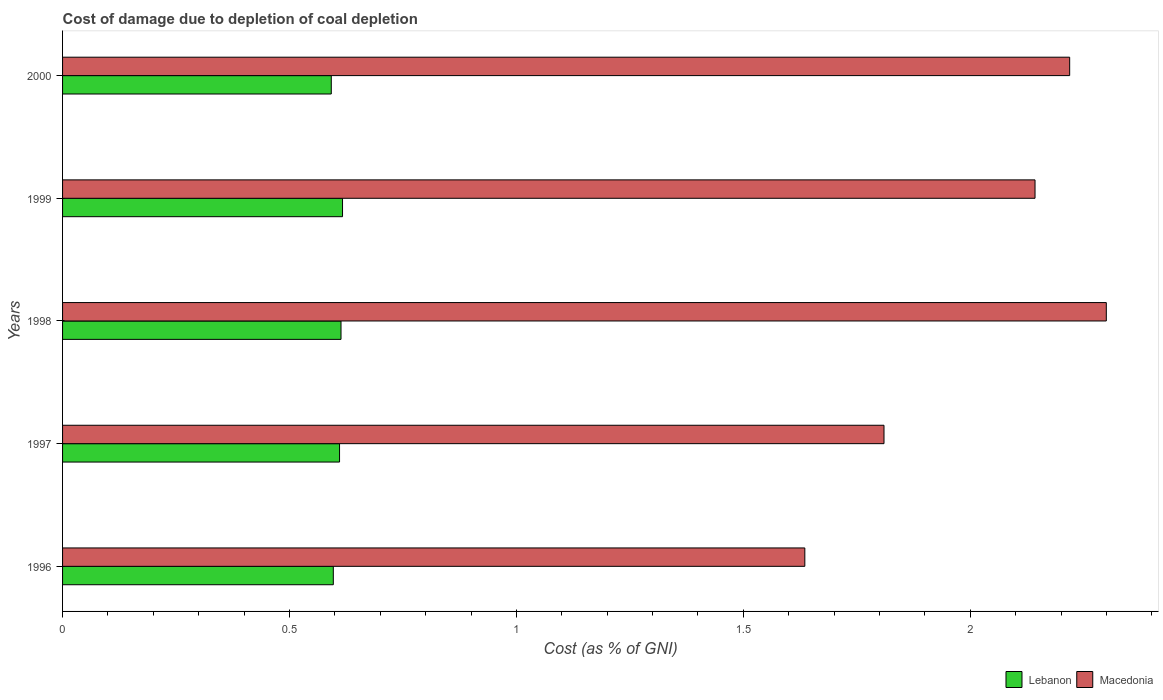How many different coloured bars are there?
Your answer should be compact. 2. How many groups of bars are there?
Provide a succinct answer. 5. Are the number of bars on each tick of the Y-axis equal?
Keep it short and to the point. Yes. How many bars are there on the 1st tick from the bottom?
Offer a terse response. 2. What is the label of the 2nd group of bars from the top?
Ensure brevity in your answer.  1999. In how many cases, is the number of bars for a given year not equal to the number of legend labels?
Provide a short and direct response. 0. What is the cost of damage caused due to coal depletion in Lebanon in 1998?
Make the answer very short. 0.61. Across all years, what is the maximum cost of damage caused due to coal depletion in Macedonia?
Ensure brevity in your answer.  2.3. Across all years, what is the minimum cost of damage caused due to coal depletion in Lebanon?
Your answer should be very brief. 0.59. In which year was the cost of damage caused due to coal depletion in Macedonia maximum?
Offer a terse response. 1998. What is the total cost of damage caused due to coal depletion in Lebanon in the graph?
Ensure brevity in your answer.  3.03. What is the difference between the cost of damage caused due to coal depletion in Lebanon in 1997 and that in 1999?
Keep it short and to the point. -0.01. What is the difference between the cost of damage caused due to coal depletion in Lebanon in 1998 and the cost of damage caused due to coal depletion in Macedonia in 1997?
Give a very brief answer. -1.2. What is the average cost of damage caused due to coal depletion in Macedonia per year?
Provide a succinct answer. 2.02. In the year 1997, what is the difference between the cost of damage caused due to coal depletion in Macedonia and cost of damage caused due to coal depletion in Lebanon?
Your answer should be compact. 1.2. What is the ratio of the cost of damage caused due to coal depletion in Lebanon in 1998 to that in 1999?
Provide a short and direct response. 0.99. What is the difference between the highest and the second highest cost of damage caused due to coal depletion in Macedonia?
Make the answer very short. 0.08. What is the difference between the highest and the lowest cost of damage caused due to coal depletion in Macedonia?
Provide a succinct answer. 0.66. What does the 2nd bar from the top in 2000 represents?
Your answer should be very brief. Lebanon. What does the 1st bar from the bottom in 1997 represents?
Offer a very short reply. Lebanon. Are all the bars in the graph horizontal?
Provide a short and direct response. Yes. What is the difference between two consecutive major ticks on the X-axis?
Provide a short and direct response. 0.5. Does the graph contain any zero values?
Give a very brief answer. No. Does the graph contain grids?
Ensure brevity in your answer.  No. How many legend labels are there?
Give a very brief answer. 2. What is the title of the graph?
Ensure brevity in your answer.  Cost of damage due to depletion of coal depletion. Does "Nepal" appear as one of the legend labels in the graph?
Give a very brief answer. No. What is the label or title of the X-axis?
Provide a succinct answer. Cost (as % of GNI). What is the Cost (as % of GNI) of Lebanon in 1996?
Make the answer very short. 0.6. What is the Cost (as % of GNI) of Macedonia in 1996?
Ensure brevity in your answer.  1.64. What is the Cost (as % of GNI) in Lebanon in 1997?
Provide a short and direct response. 0.61. What is the Cost (as % of GNI) of Macedonia in 1997?
Ensure brevity in your answer.  1.81. What is the Cost (as % of GNI) of Lebanon in 1998?
Provide a short and direct response. 0.61. What is the Cost (as % of GNI) of Macedonia in 1998?
Offer a very short reply. 2.3. What is the Cost (as % of GNI) in Lebanon in 1999?
Keep it short and to the point. 0.62. What is the Cost (as % of GNI) of Macedonia in 1999?
Give a very brief answer. 2.14. What is the Cost (as % of GNI) in Lebanon in 2000?
Ensure brevity in your answer.  0.59. What is the Cost (as % of GNI) of Macedonia in 2000?
Give a very brief answer. 2.22. Across all years, what is the maximum Cost (as % of GNI) of Lebanon?
Provide a succinct answer. 0.62. Across all years, what is the maximum Cost (as % of GNI) of Macedonia?
Give a very brief answer. 2.3. Across all years, what is the minimum Cost (as % of GNI) in Lebanon?
Keep it short and to the point. 0.59. Across all years, what is the minimum Cost (as % of GNI) in Macedonia?
Provide a short and direct response. 1.64. What is the total Cost (as % of GNI) in Lebanon in the graph?
Provide a short and direct response. 3.03. What is the total Cost (as % of GNI) of Macedonia in the graph?
Ensure brevity in your answer.  10.11. What is the difference between the Cost (as % of GNI) of Lebanon in 1996 and that in 1997?
Ensure brevity in your answer.  -0.01. What is the difference between the Cost (as % of GNI) of Macedonia in 1996 and that in 1997?
Provide a short and direct response. -0.17. What is the difference between the Cost (as % of GNI) in Lebanon in 1996 and that in 1998?
Make the answer very short. -0.02. What is the difference between the Cost (as % of GNI) of Macedonia in 1996 and that in 1998?
Provide a succinct answer. -0.66. What is the difference between the Cost (as % of GNI) in Lebanon in 1996 and that in 1999?
Your answer should be very brief. -0.02. What is the difference between the Cost (as % of GNI) of Macedonia in 1996 and that in 1999?
Your answer should be compact. -0.51. What is the difference between the Cost (as % of GNI) in Lebanon in 1996 and that in 2000?
Offer a very short reply. 0. What is the difference between the Cost (as % of GNI) of Macedonia in 1996 and that in 2000?
Offer a very short reply. -0.58. What is the difference between the Cost (as % of GNI) in Lebanon in 1997 and that in 1998?
Offer a terse response. -0. What is the difference between the Cost (as % of GNI) in Macedonia in 1997 and that in 1998?
Your answer should be compact. -0.49. What is the difference between the Cost (as % of GNI) in Lebanon in 1997 and that in 1999?
Make the answer very short. -0.01. What is the difference between the Cost (as % of GNI) in Macedonia in 1997 and that in 1999?
Your answer should be compact. -0.33. What is the difference between the Cost (as % of GNI) in Lebanon in 1997 and that in 2000?
Provide a short and direct response. 0.02. What is the difference between the Cost (as % of GNI) of Macedonia in 1997 and that in 2000?
Your answer should be very brief. -0.41. What is the difference between the Cost (as % of GNI) of Lebanon in 1998 and that in 1999?
Provide a succinct answer. -0. What is the difference between the Cost (as % of GNI) in Macedonia in 1998 and that in 1999?
Provide a succinct answer. 0.16. What is the difference between the Cost (as % of GNI) in Lebanon in 1998 and that in 2000?
Provide a succinct answer. 0.02. What is the difference between the Cost (as % of GNI) in Macedonia in 1998 and that in 2000?
Make the answer very short. 0.08. What is the difference between the Cost (as % of GNI) of Lebanon in 1999 and that in 2000?
Make the answer very short. 0.02. What is the difference between the Cost (as % of GNI) in Macedonia in 1999 and that in 2000?
Provide a short and direct response. -0.08. What is the difference between the Cost (as % of GNI) of Lebanon in 1996 and the Cost (as % of GNI) of Macedonia in 1997?
Your answer should be very brief. -1.21. What is the difference between the Cost (as % of GNI) of Lebanon in 1996 and the Cost (as % of GNI) of Macedonia in 1998?
Your answer should be very brief. -1.7. What is the difference between the Cost (as % of GNI) of Lebanon in 1996 and the Cost (as % of GNI) of Macedonia in 1999?
Provide a short and direct response. -1.55. What is the difference between the Cost (as % of GNI) of Lebanon in 1996 and the Cost (as % of GNI) of Macedonia in 2000?
Your response must be concise. -1.62. What is the difference between the Cost (as % of GNI) of Lebanon in 1997 and the Cost (as % of GNI) of Macedonia in 1998?
Your answer should be compact. -1.69. What is the difference between the Cost (as % of GNI) in Lebanon in 1997 and the Cost (as % of GNI) in Macedonia in 1999?
Provide a succinct answer. -1.53. What is the difference between the Cost (as % of GNI) of Lebanon in 1997 and the Cost (as % of GNI) of Macedonia in 2000?
Provide a short and direct response. -1.61. What is the difference between the Cost (as % of GNI) of Lebanon in 1998 and the Cost (as % of GNI) of Macedonia in 1999?
Your answer should be compact. -1.53. What is the difference between the Cost (as % of GNI) in Lebanon in 1998 and the Cost (as % of GNI) in Macedonia in 2000?
Offer a terse response. -1.61. What is the difference between the Cost (as % of GNI) of Lebanon in 1999 and the Cost (as % of GNI) of Macedonia in 2000?
Provide a succinct answer. -1.6. What is the average Cost (as % of GNI) of Lebanon per year?
Give a very brief answer. 0.61. What is the average Cost (as % of GNI) of Macedonia per year?
Provide a succinct answer. 2.02. In the year 1996, what is the difference between the Cost (as % of GNI) in Lebanon and Cost (as % of GNI) in Macedonia?
Ensure brevity in your answer.  -1.04. In the year 1997, what is the difference between the Cost (as % of GNI) of Lebanon and Cost (as % of GNI) of Macedonia?
Provide a short and direct response. -1.2. In the year 1998, what is the difference between the Cost (as % of GNI) in Lebanon and Cost (as % of GNI) in Macedonia?
Offer a very short reply. -1.69. In the year 1999, what is the difference between the Cost (as % of GNI) in Lebanon and Cost (as % of GNI) in Macedonia?
Offer a very short reply. -1.53. In the year 2000, what is the difference between the Cost (as % of GNI) in Lebanon and Cost (as % of GNI) in Macedonia?
Your answer should be very brief. -1.63. What is the ratio of the Cost (as % of GNI) of Lebanon in 1996 to that in 1997?
Your answer should be very brief. 0.98. What is the ratio of the Cost (as % of GNI) of Macedonia in 1996 to that in 1997?
Ensure brevity in your answer.  0.9. What is the ratio of the Cost (as % of GNI) in Lebanon in 1996 to that in 1998?
Your response must be concise. 0.97. What is the ratio of the Cost (as % of GNI) of Macedonia in 1996 to that in 1998?
Provide a short and direct response. 0.71. What is the ratio of the Cost (as % of GNI) in Lebanon in 1996 to that in 1999?
Offer a very short reply. 0.97. What is the ratio of the Cost (as % of GNI) of Macedonia in 1996 to that in 1999?
Give a very brief answer. 0.76. What is the ratio of the Cost (as % of GNI) in Lebanon in 1996 to that in 2000?
Keep it short and to the point. 1.01. What is the ratio of the Cost (as % of GNI) in Macedonia in 1996 to that in 2000?
Ensure brevity in your answer.  0.74. What is the ratio of the Cost (as % of GNI) in Lebanon in 1997 to that in 1998?
Ensure brevity in your answer.  0.99. What is the ratio of the Cost (as % of GNI) of Macedonia in 1997 to that in 1998?
Your answer should be very brief. 0.79. What is the ratio of the Cost (as % of GNI) in Macedonia in 1997 to that in 1999?
Ensure brevity in your answer.  0.84. What is the ratio of the Cost (as % of GNI) of Lebanon in 1997 to that in 2000?
Keep it short and to the point. 1.03. What is the ratio of the Cost (as % of GNI) in Macedonia in 1997 to that in 2000?
Provide a succinct answer. 0.82. What is the ratio of the Cost (as % of GNI) of Macedonia in 1998 to that in 1999?
Keep it short and to the point. 1.07. What is the ratio of the Cost (as % of GNI) of Lebanon in 1998 to that in 2000?
Your answer should be compact. 1.04. What is the ratio of the Cost (as % of GNI) of Macedonia in 1998 to that in 2000?
Your answer should be very brief. 1.04. What is the ratio of the Cost (as % of GNI) in Lebanon in 1999 to that in 2000?
Your answer should be compact. 1.04. What is the ratio of the Cost (as % of GNI) of Macedonia in 1999 to that in 2000?
Offer a very short reply. 0.97. What is the difference between the highest and the second highest Cost (as % of GNI) in Lebanon?
Provide a short and direct response. 0. What is the difference between the highest and the second highest Cost (as % of GNI) in Macedonia?
Keep it short and to the point. 0.08. What is the difference between the highest and the lowest Cost (as % of GNI) in Lebanon?
Provide a short and direct response. 0.02. What is the difference between the highest and the lowest Cost (as % of GNI) of Macedonia?
Make the answer very short. 0.66. 